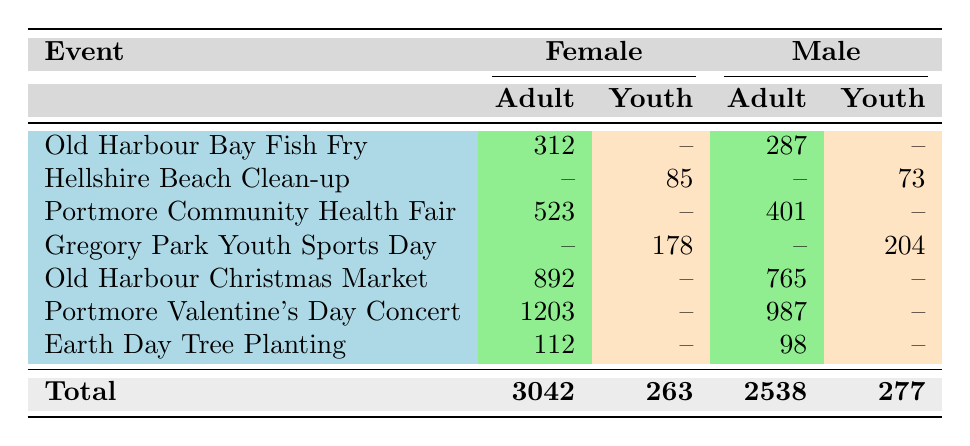What is the total attendance of female adults at all events? By reviewing the table, the female adult attendance can be summed as follows: 312 (Old Harbour Bay Fish Fry) + 523 (Portmore Community Health Fair) + 892 (Old Harbour Christmas Market) + 1203 (Portmore Valentine's Day Concert) + 112 (Earth Day Tree Planting) = 3042
Answer: 3042 How many male youths participated in events? The table shows that only the Gregory Park Youth Sports Day event has a male youth participation, which totals to 204.
Answer: 204 What was the highest attendance for a community event? Inspecting the attendance numbers, the Portmore Valentine's Day Concert had the highest attendance with 1203.
Answer: 1203 Is there a youth attendance for the Old Harbour Christmas Market? The table shows no youth attendance for the Old Harbour Christmas Market, as it's listed only under adult participation.
Answer: No What is the difference between the total female adult and male adult attendance? The total female adult attendance is 3042, while the total male adult attendance is 2538. The difference is thus 3042 - 2538 = 504.
Answer: 504 Which event had the lowest attendance and what was it? Looking through the table, the event with the lowest attendance is the Earth Day Tree Planting with 112 attendees.
Answer: Earth Day Tree Planting What percentage of the total attendance is represented by female youth? First, total male youth attendance is found to be 277 and total female youth attendance is 263 from the table. Therefore, calculating the percentage of female youth: (263 / (3042 + 263 + 2538 + 277)) * 100 = 8.93%.
Answer: 8.93% Did the Hellshire Beach Clean-up event include any adult participation? By examining the attendance columns, the Hellshire Beach Clean-up event only includes youth participation and no adult attendance, confirming it is true.
Answer: No What can be said about the overall trend in attendance for female participants compared to male participants in this data? By examining the sums, female attendance stands at 3042 while male attendance is 2538. This indicates female participation is higher, suggesting a potential trend in community engagement among females.
Answer: Female attendance is higher than male attendance 